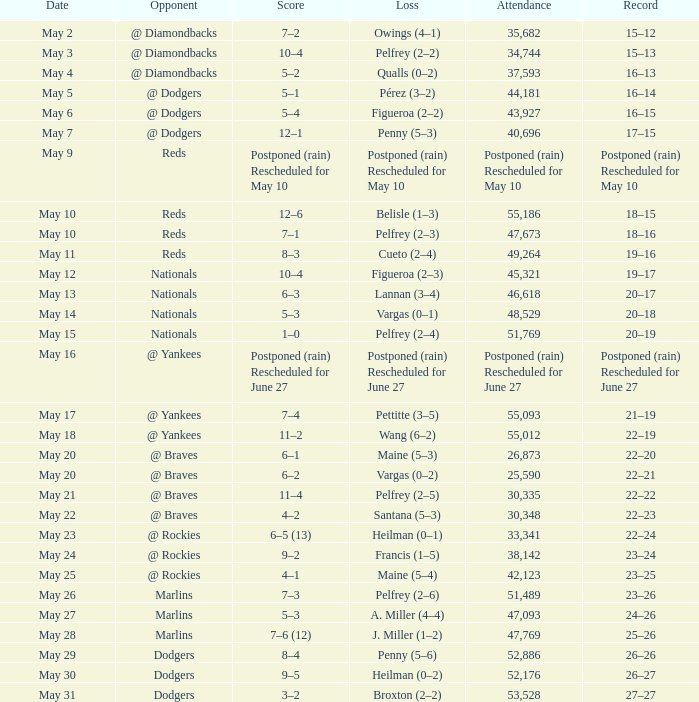How much loss was incurred in the postponed game rescheduled for june 27 because of rain? Postponed (rain) Rescheduled for June 27. 